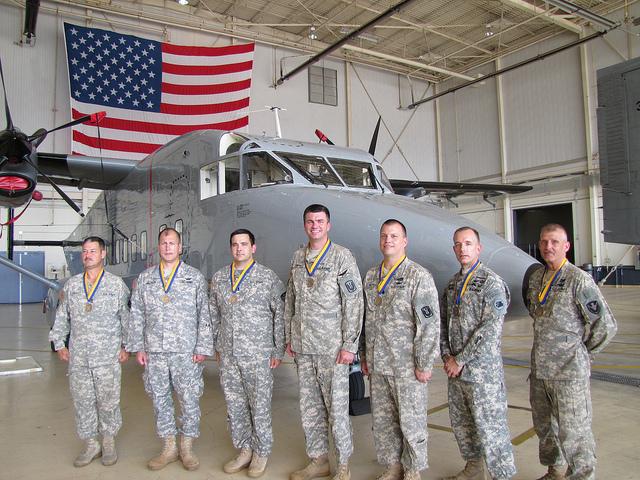Are these men in the Service?
Keep it brief. Yes. What color is the rope?
Concise answer only. Brown. What are the men wearing?
Short answer required. Uniforms. Is that an American flag on the wall?
Concise answer only. Yes. 